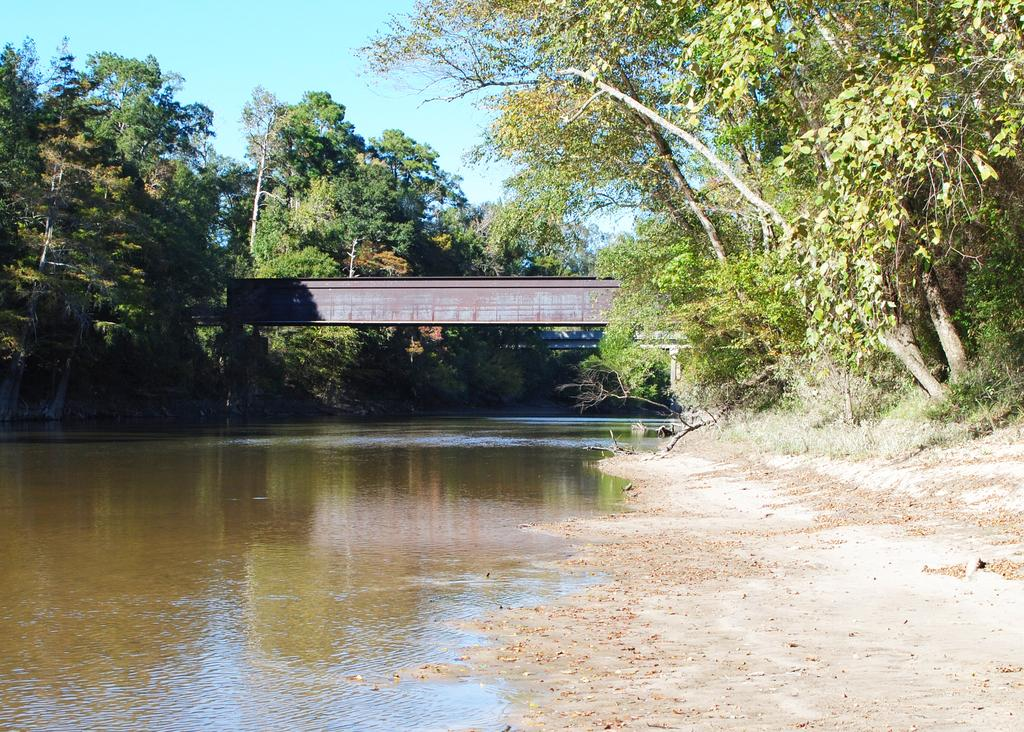What type of structure can be seen in the image? There is a bridge in the image. What natural elements are present in the image? There are trees and a river in the image. What type of terrain can be seen in the image? There is sand visible in the image. What part of the natural environment is visible in the image? The sky is visible in the image. How does the person in the image comb their hair? There is no person present in the image, so it is not possible to determine how their hair is being combed. 